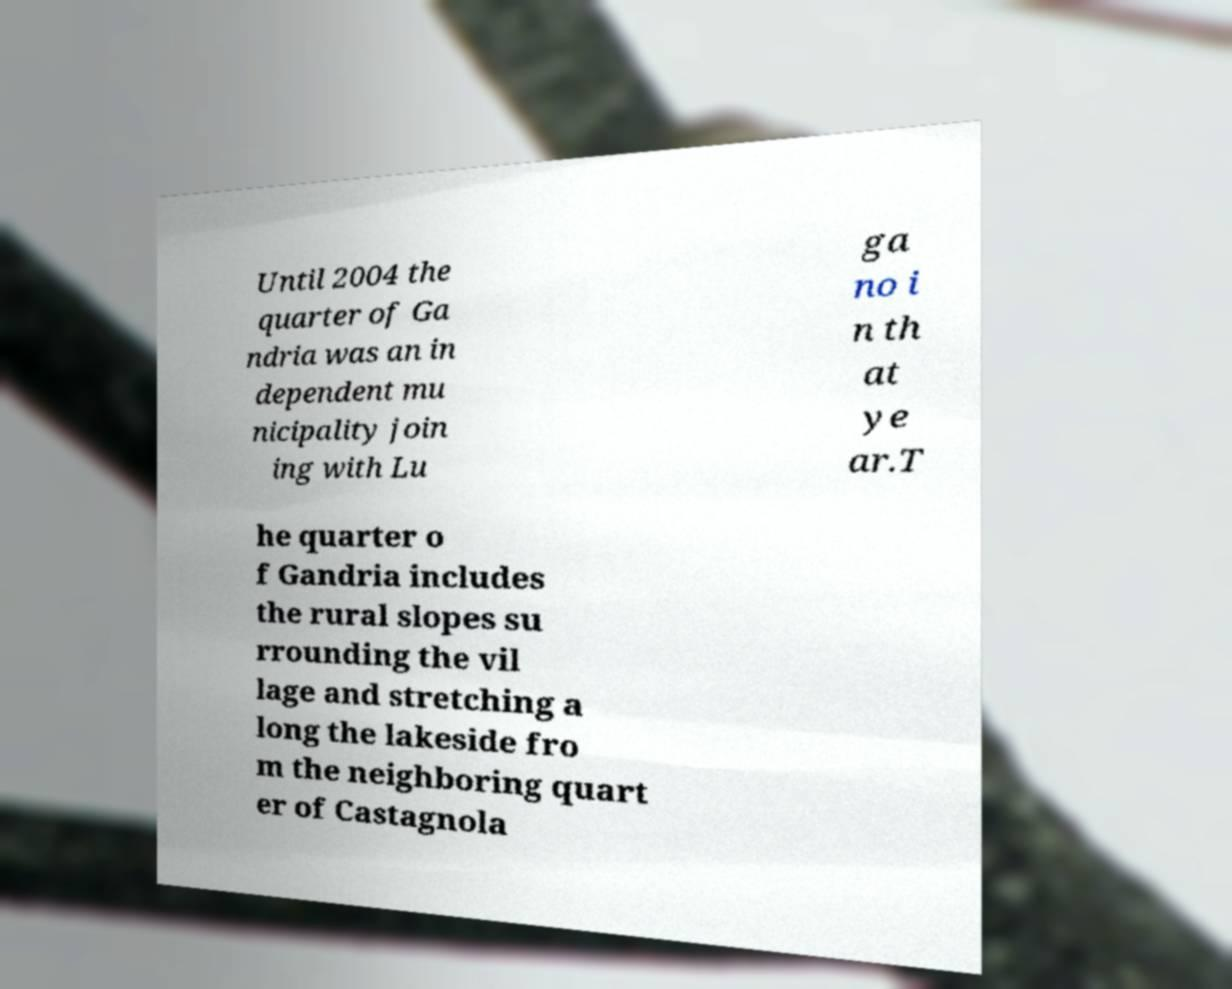For documentation purposes, I need the text within this image transcribed. Could you provide that? Until 2004 the quarter of Ga ndria was an in dependent mu nicipality join ing with Lu ga no i n th at ye ar.T he quarter o f Gandria includes the rural slopes su rrounding the vil lage and stretching a long the lakeside fro m the neighboring quart er of Castagnola 